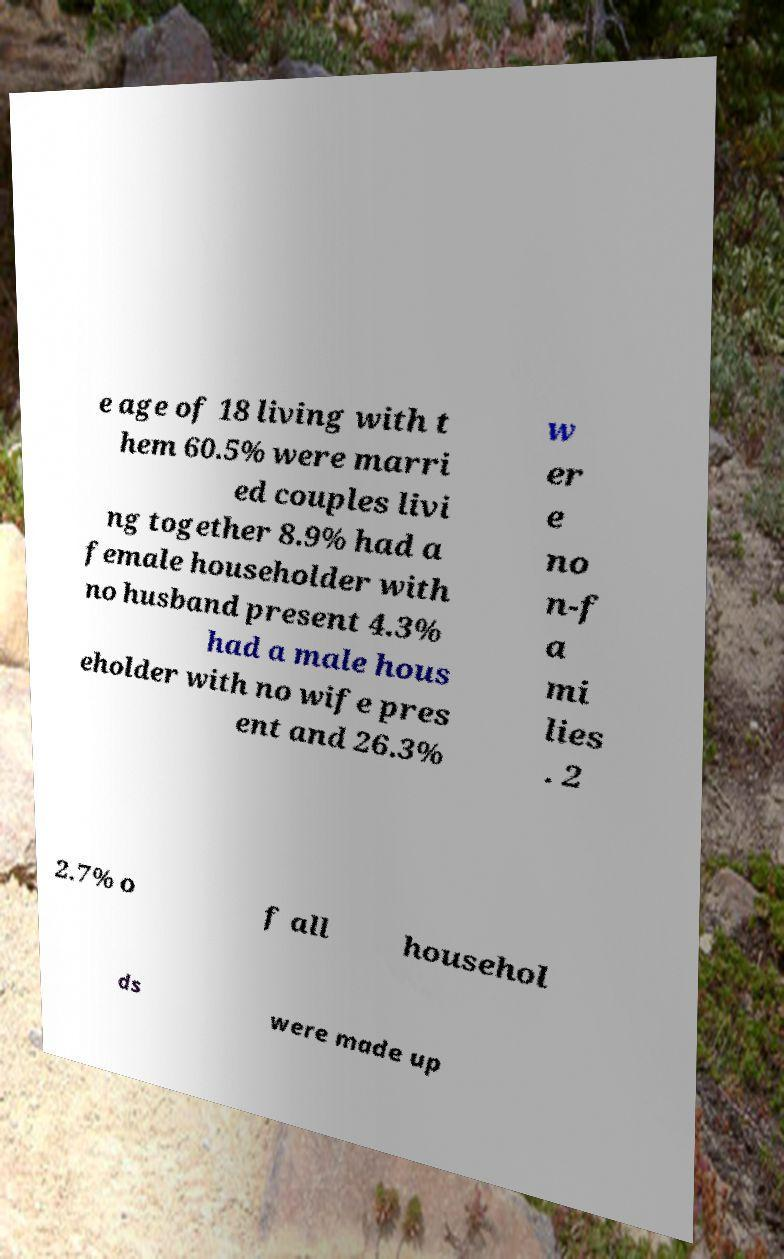Please identify and transcribe the text found in this image. e age of 18 living with t hem 60.5% were marri ed couples livi ng together 8.9% had a female householder with no husband present 4.3% had a male hous eholder with no wife pres ent and 26.3% w er e no n-f a mi lies . 2 2.7% o f all househol ds were made up 